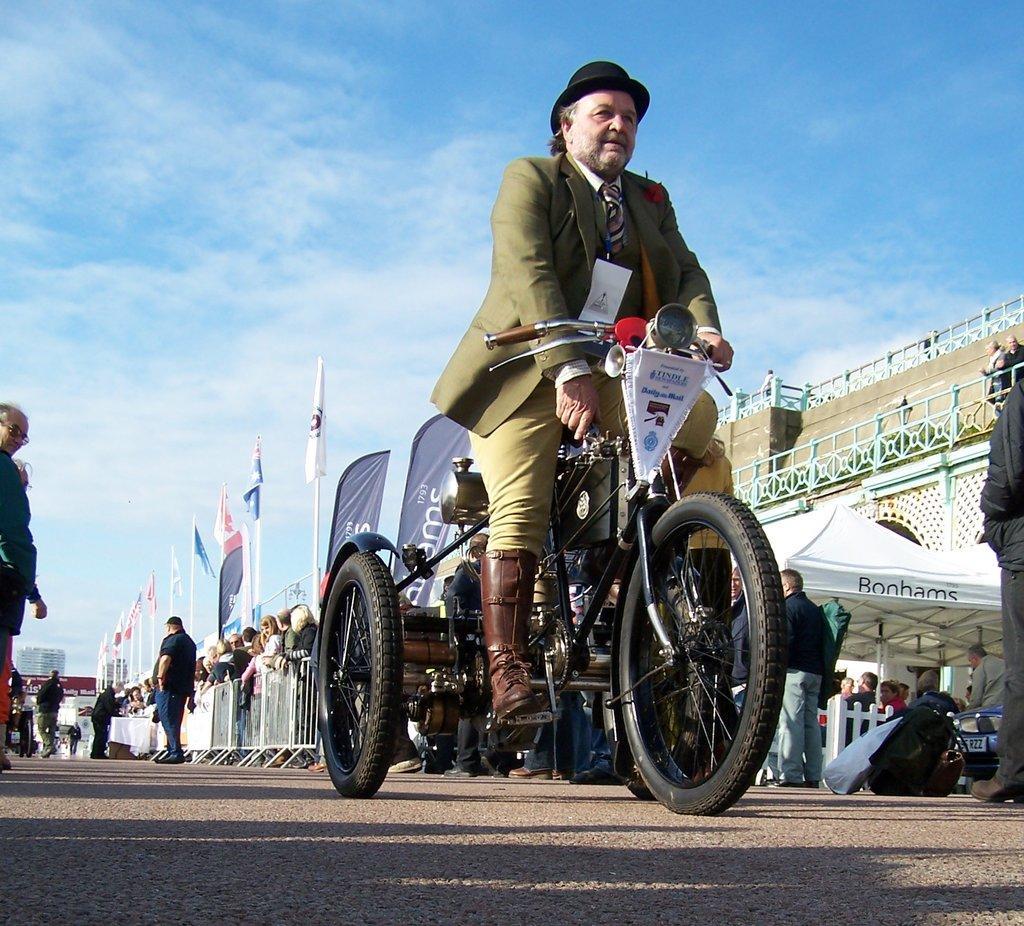Can you describe this image briefly? This is a picture taken in the outdoor, the am riding a vehicle. The people are standing on the road and the people are watching the person and the vehicles. The background of the person is a sky with clouds. 